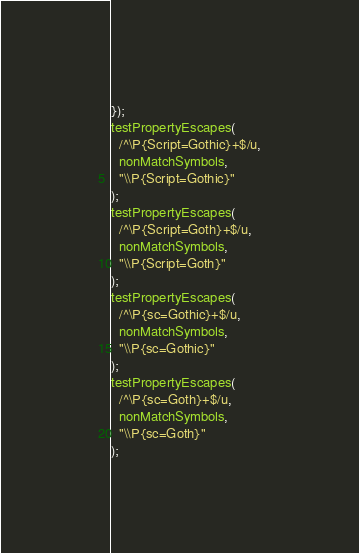Convert code to text. <code><loc_0><loc_0><loc_500><loc_500><_JavaScript_>});
testPropertyEscapes(
  /^\P{Script=Gothic}+$/u,
  nonMatchSymbols,
  "\\P{Script=Gothic}"
);
testPropertyEscapes(
  /^\P{Script=Goth}+$/u,
  nonMatchSymbols,
  "\\P{Script=Goth}"
);
testPropertyEscapes(
  /^\P{sc=Gothic}+$/u,
  nonMatchSymbols,
  "\\P{sc=Gothic}"
);
testPropertyEscapes(
  /^\P{sc=Goth}+$/u,
  nonMatchSymbols,
  "\\P{sc=Goth}"
);
</code> 